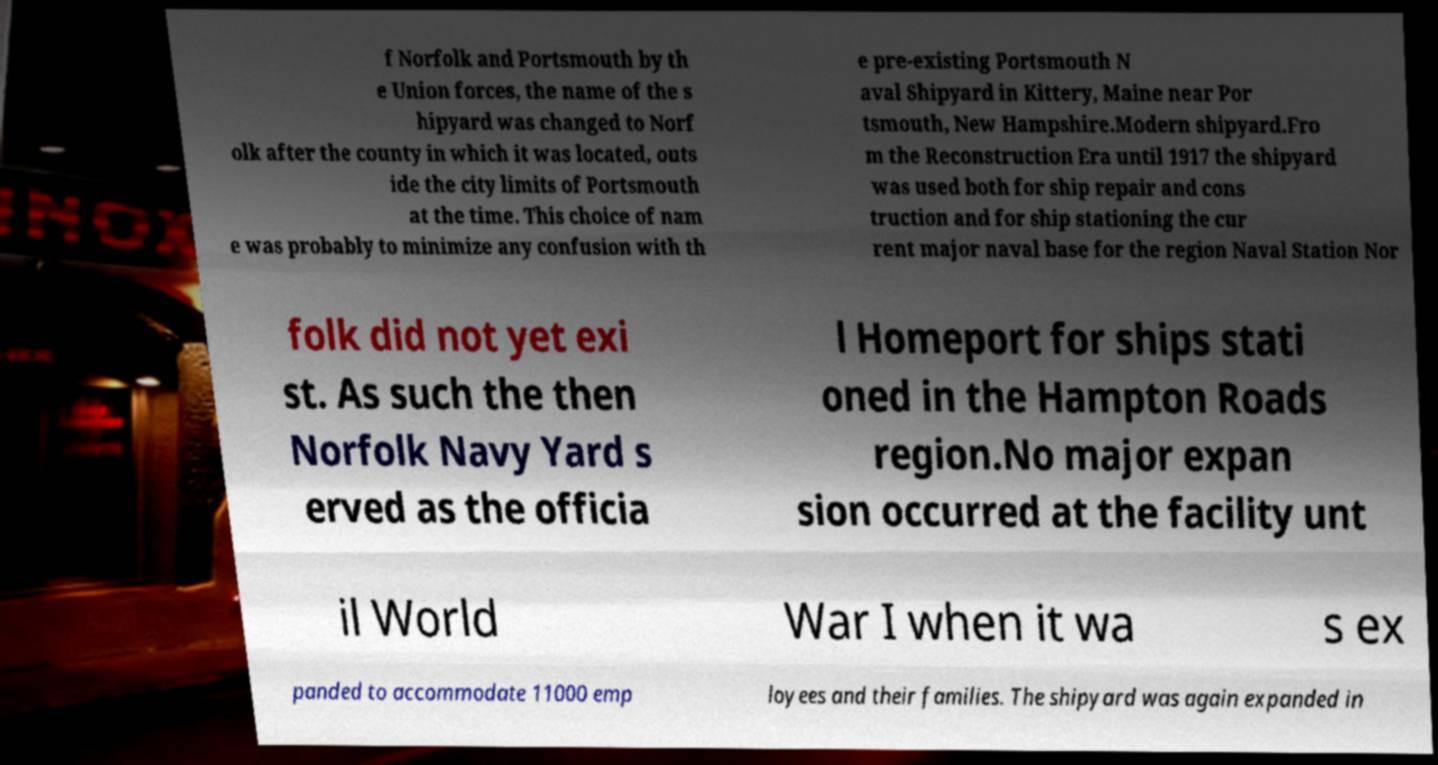Could you assist in decoding the text presented in this image and type it out clearly? f Norfolk and Portsmouth by th e Union forces, the name of the s hipyard was changed to Norf olk after the county in which it was located, outs ide the city limits of Portsmouth at the time. This choice of nam e was probably to minimize any confusion with th e pre-existing Portsmouth N aval Shipyard in Kittery, Maine near Por tsmouth, New Hampshire.Modern shipyard.Fro m the Reconstruction Era until 1917 the shipyard was used both for ship repair and cons truction and for ship stationing the cur rent major naval base for the region Naval Station Nor folk did not yet exi st. As such the then Norfolk Navy Yard s erved as the officia l Homeport for ships stati oned in the Hampton Roads region.No major expan sion occurred at the facility unt il World War I when it wa s ex panded to accommodate 11000 emp loyees and their families. The shipyard was again expanded in 